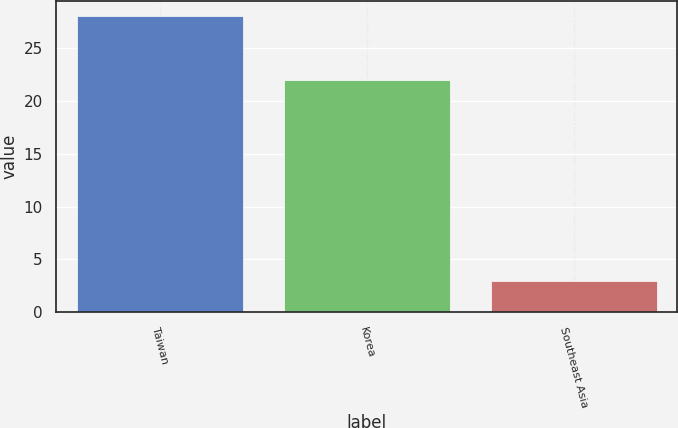Convert chart. <chart><loc_0><loc_0><loc_500><loc_500><bar_chart><fcel>Taiwan<fcel>Korea<fcel>Southeast Asia<nl><fcel>28<fcel>22<fcel>3<nl></chart> 